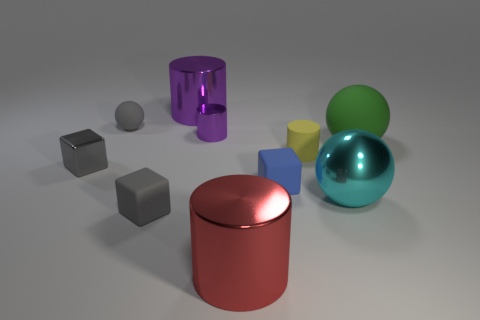The tiny matte object right of the blue object is what color?
Offer a terse response. Yellow. There is a large rubber object that is the same shape as the big cyan metal thing; what color is it?
Offer a terse response. Green. Is there anything else that has the same color as the tiny shiny cylinder?
Your answer should be very brief. Yes. Is the number of big rubber blocks greater than the number of green matte objects?
Ensure brevity in your answer.  No. Is the tiny yellow cylinder made of the same material as the large cyan ball?
Keep it short and to the point. No. What number of other large objects have the same material as the big cyan thing?
Provide a short and direct response. 2. There is a yellow matte object; is it the same size as the metallic thing that is right of the red metal object?
Ensure brevity in your answer.  No. There is a big object that is behind the tiny metallic block and in front of the gray matte ball; what is its color?
Provide a short and direct response. Green. There is a tiny matte thing that is in front of the big cyan metal thing; are there any small rubber blocks right of it?
Your response must be concise. Yes. Is the number of big green matte things that are to the left of the gray metallic cube the same as the number of small green matte cubes?
Keep it short and to the point. Yes. 